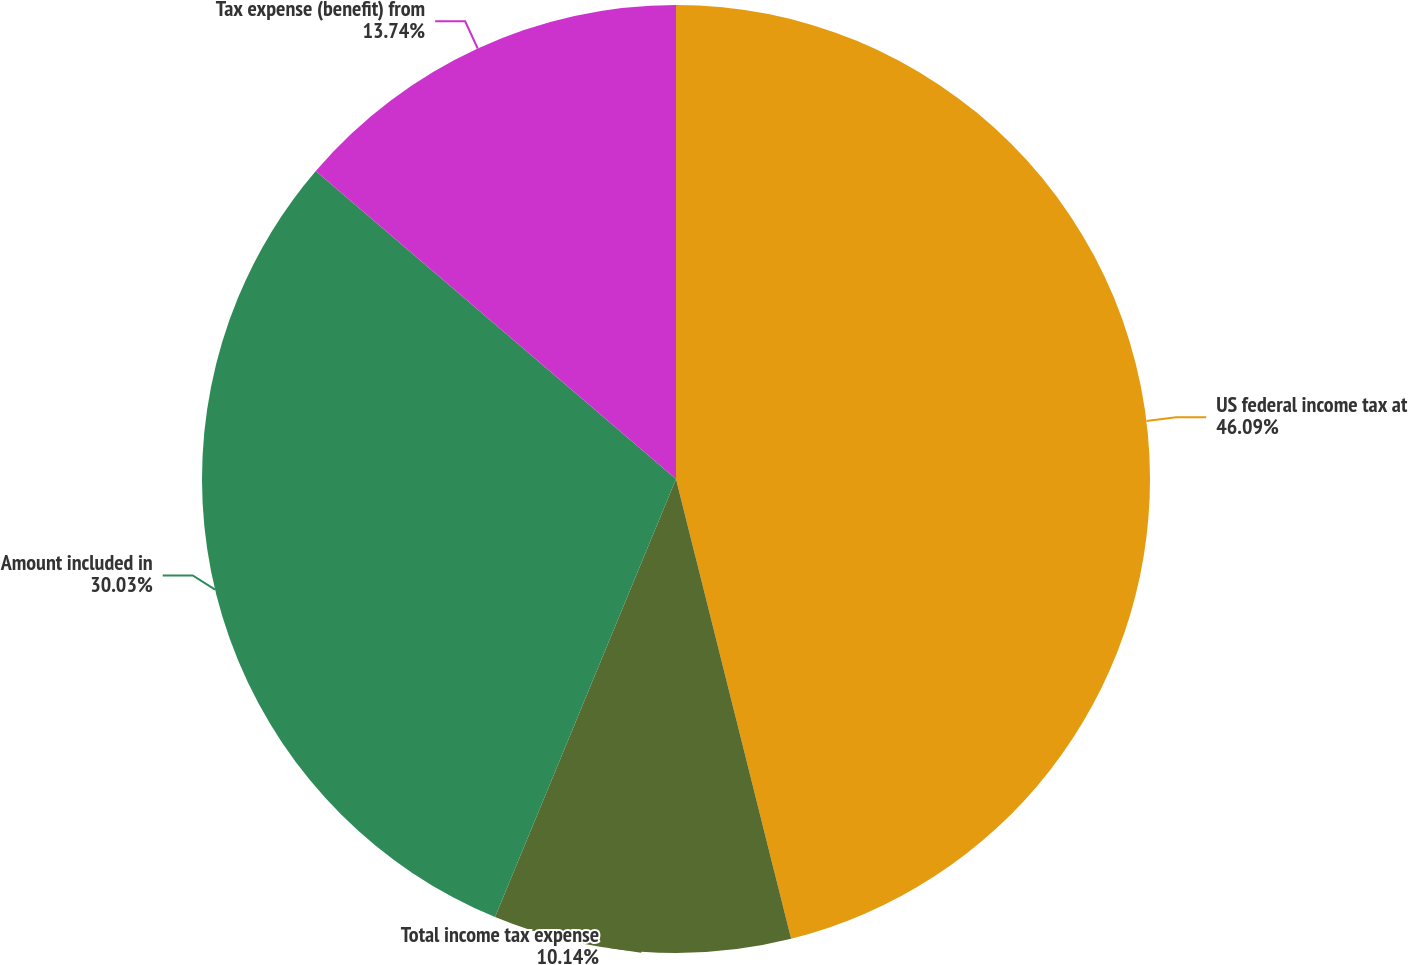Convert chart to OTSL. <chart><loc_0><loc_0><loc_500><loc_500><pie_chart><fcel>US federal income tax at<fcel>Total income tax expense<fcel>Amount included in<fcel>Tax expense (benefit) from<nl><fcel>46.1%<fcel>10.14%<fcel>30.03%<fcel>13.74%<nl></chart> 